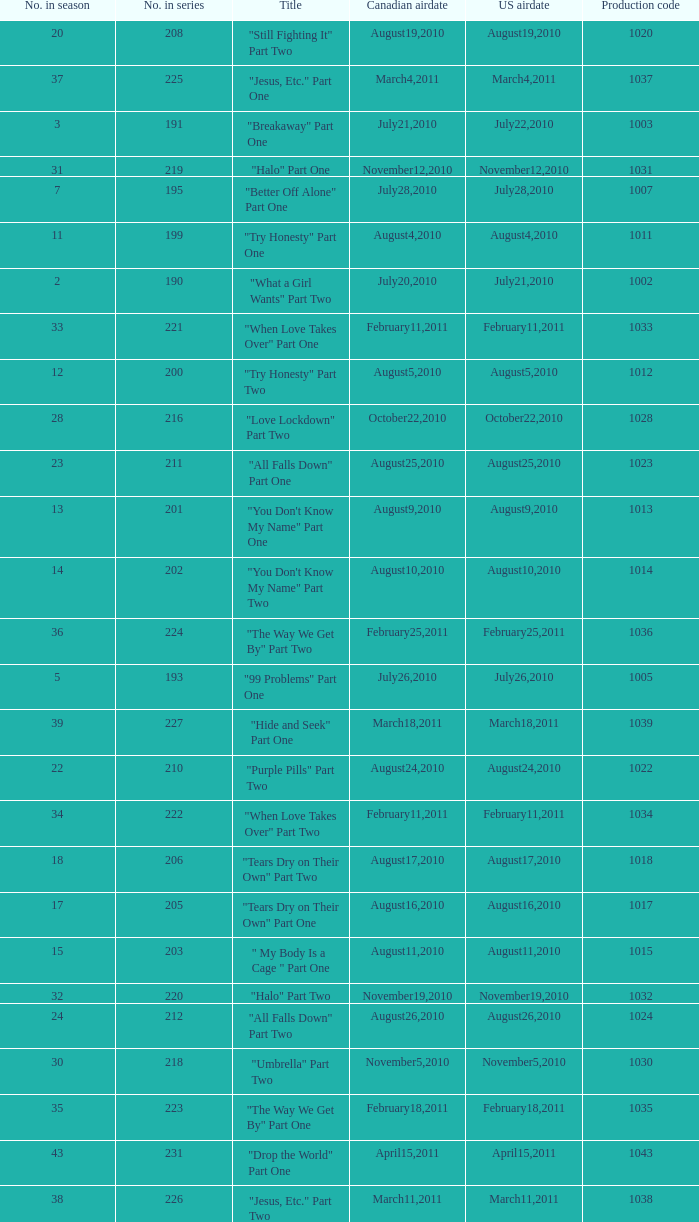What was the us airdate of "love lockdown" part one? October15,2010. 